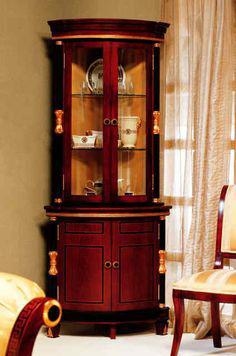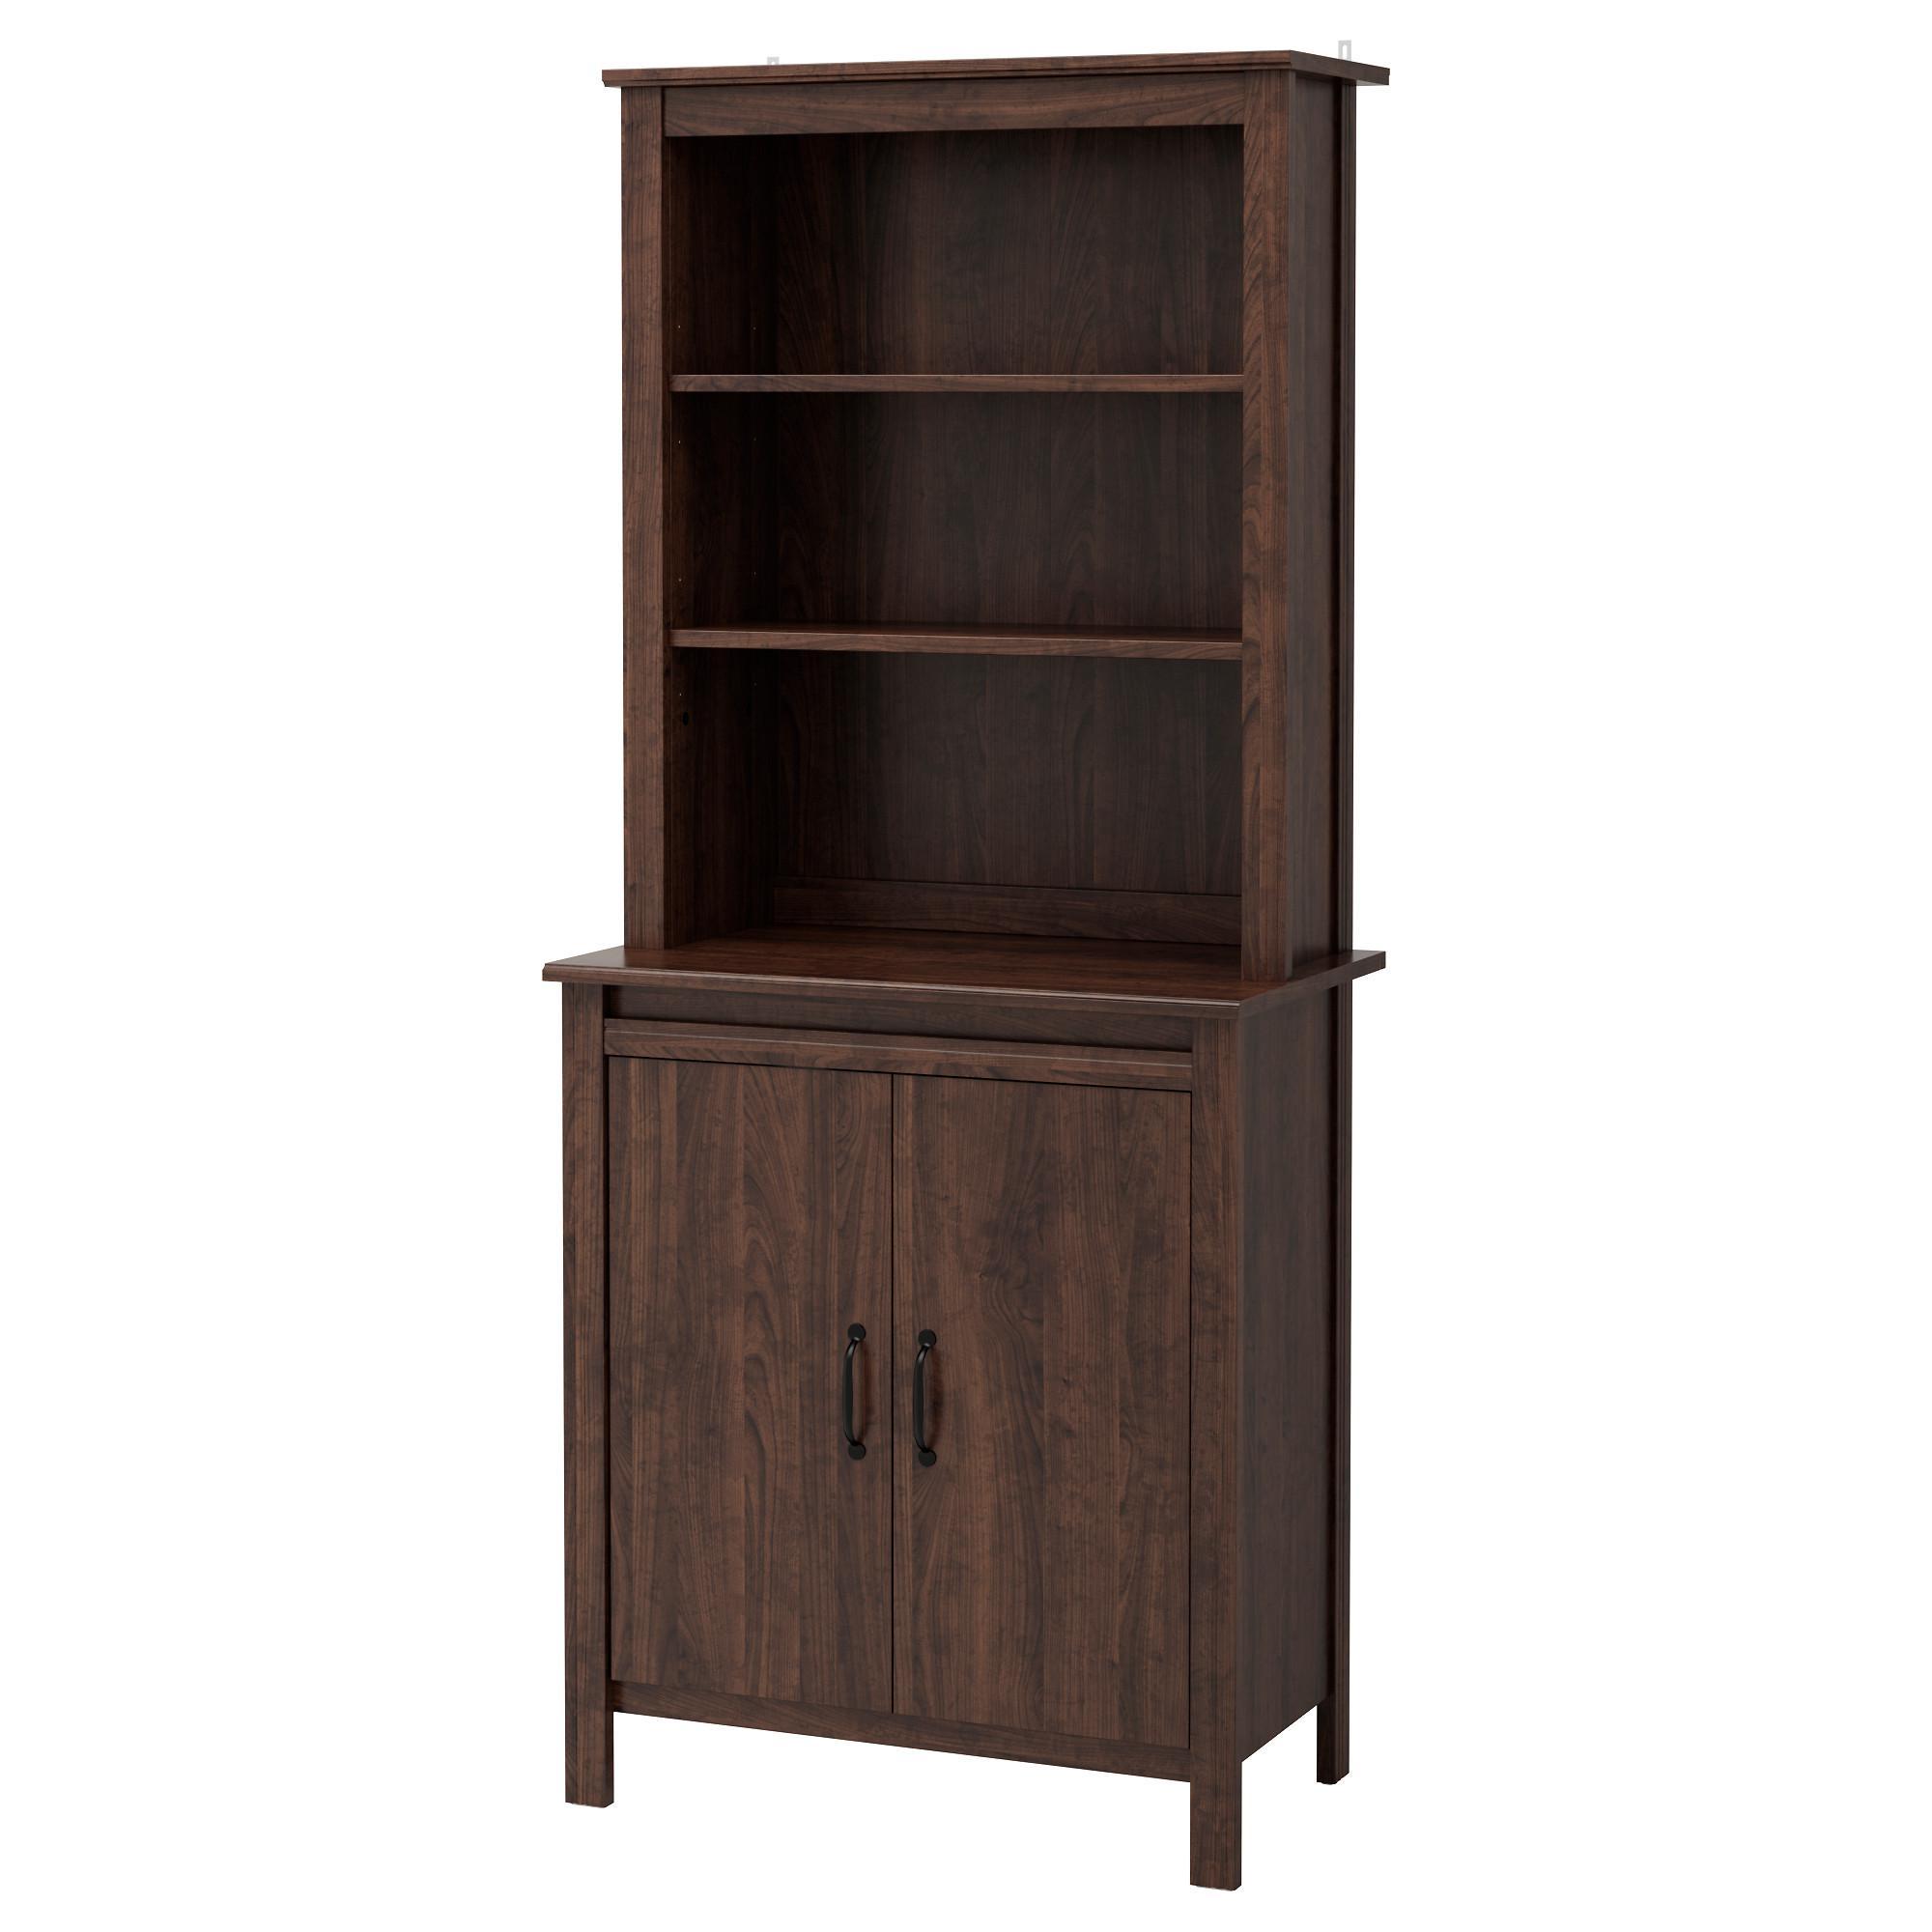The first image is the image on the left, the second image is the image on the right. Given the left and right images, does the statement "The cabinet in the image on the right is bare." hold true? Answer yes or no. Yes. The first image is the image on the left, the second image is the image on the right. Analyze the images presented: Is the assertion "There is no less than one hutch that is completely empty" valid? Answer yes or no. Yes. 